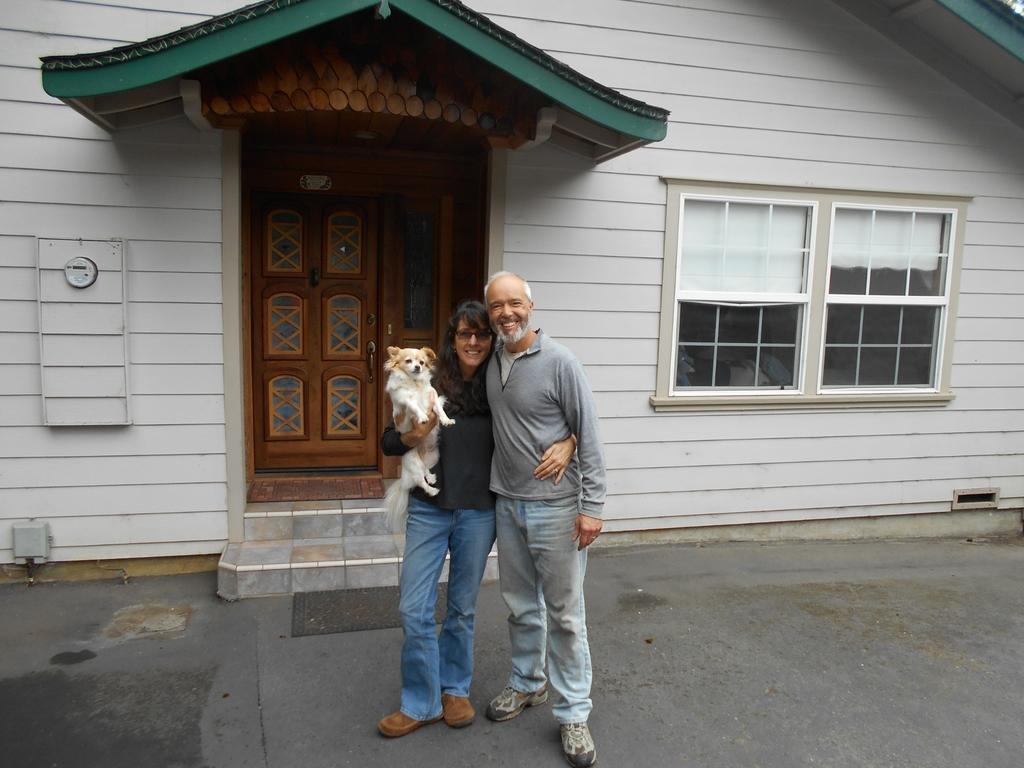In one or two sentences, can you explain what this image depicts? In this image there is a couple holding a dog in their hands is standing on the surface with a smile on their face, behind them there is a house with a wooden door and a glass window. 